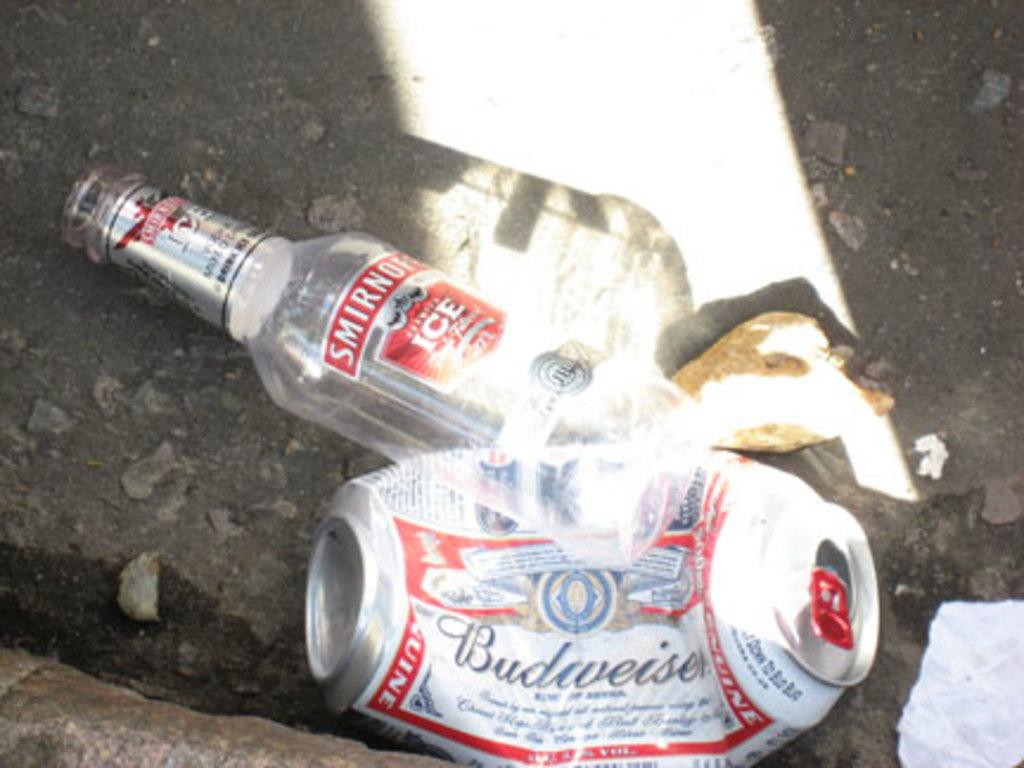Provide a one-sentence caption for the provided image. Crushed Budweiser can next to an empty Smirnoff bottle. 